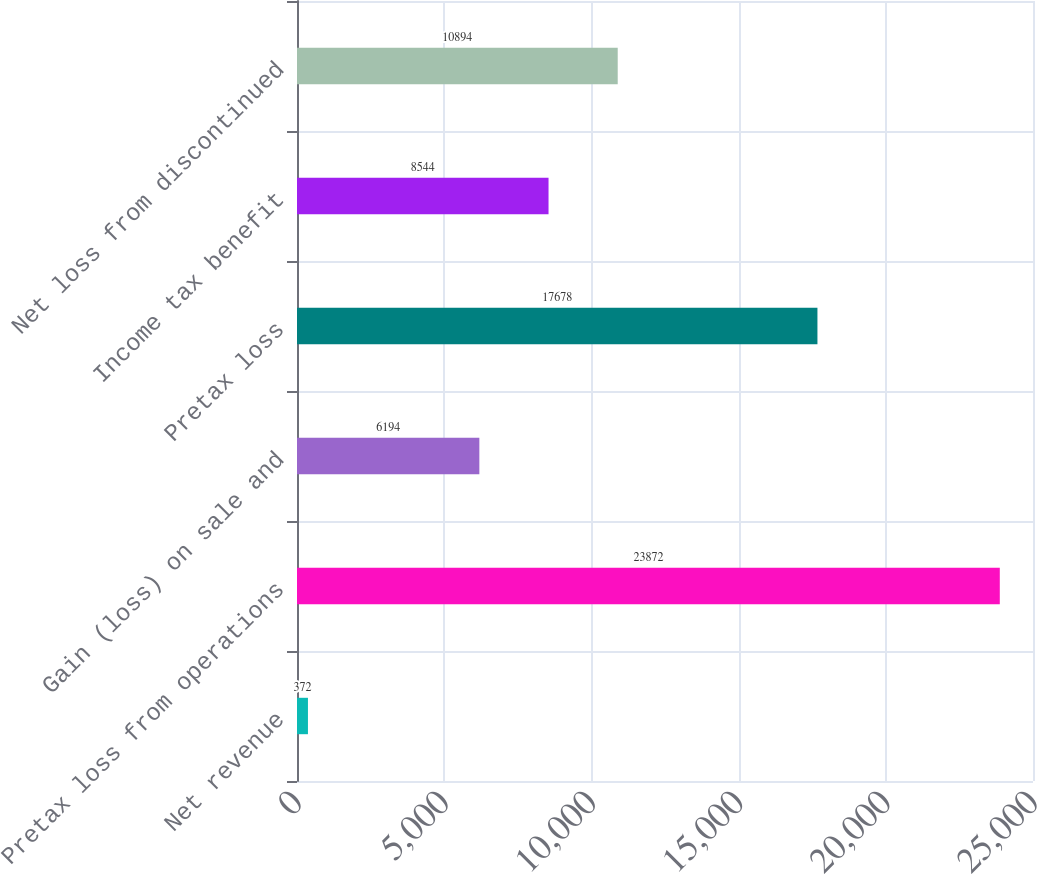Convert chart to OTSL. <chart><loc_0><loc_0><loc_500><loc_500><bar_chart><fcel>Net revenue<fcel>Pretax loss from operations<fcel>Gain (loss) on sale and<fcel>Pretax loss<fcel>Income tax benefit<fcel>Net loss from discontinued<nl><fcel>372<fcel>23872<fcel>6194<fcel>17678<fcel>8544<fcel>10894<nl></chart> 